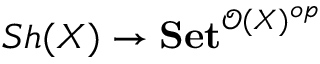Convert formula to latex. <formula><loc_0><loc_0><loc_500><loc_500>S h ( X ) \to S e t ^ { { \mathcal { O } } ( X ) ^ { o p } }</formula> 